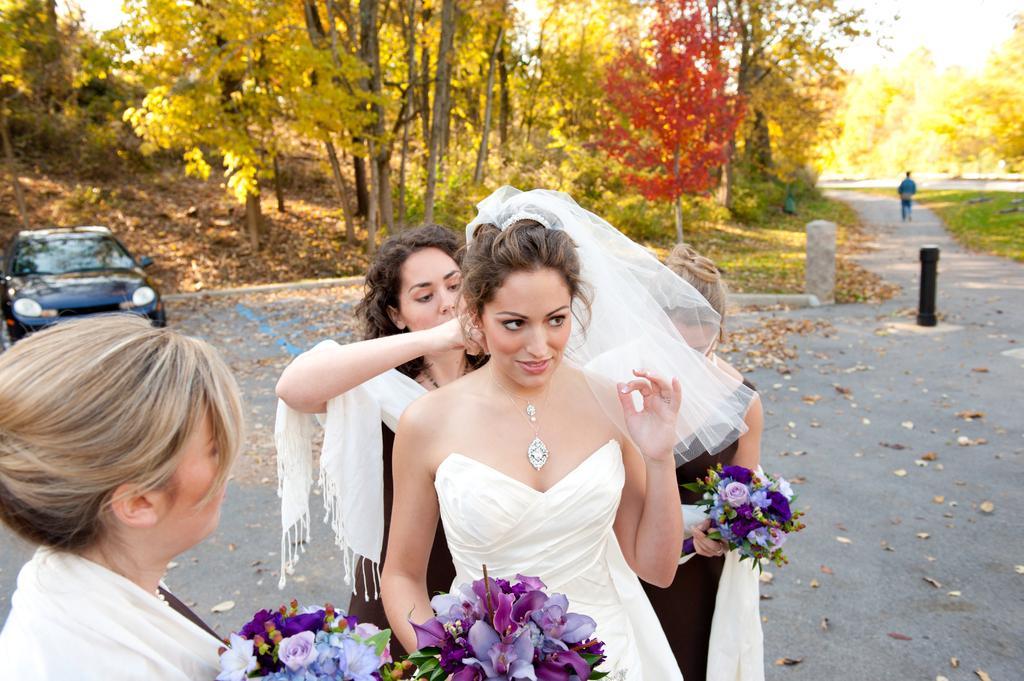Describe this image in one or two sentences. In this image we can see few women are standing on the road and a woman among them is holding flower bouquet in her hands. At the bottom we can see flower bouquets. In the background we can see a car and a person is walking on the road, trees, grass on the ground, sky and leaves on the road. 